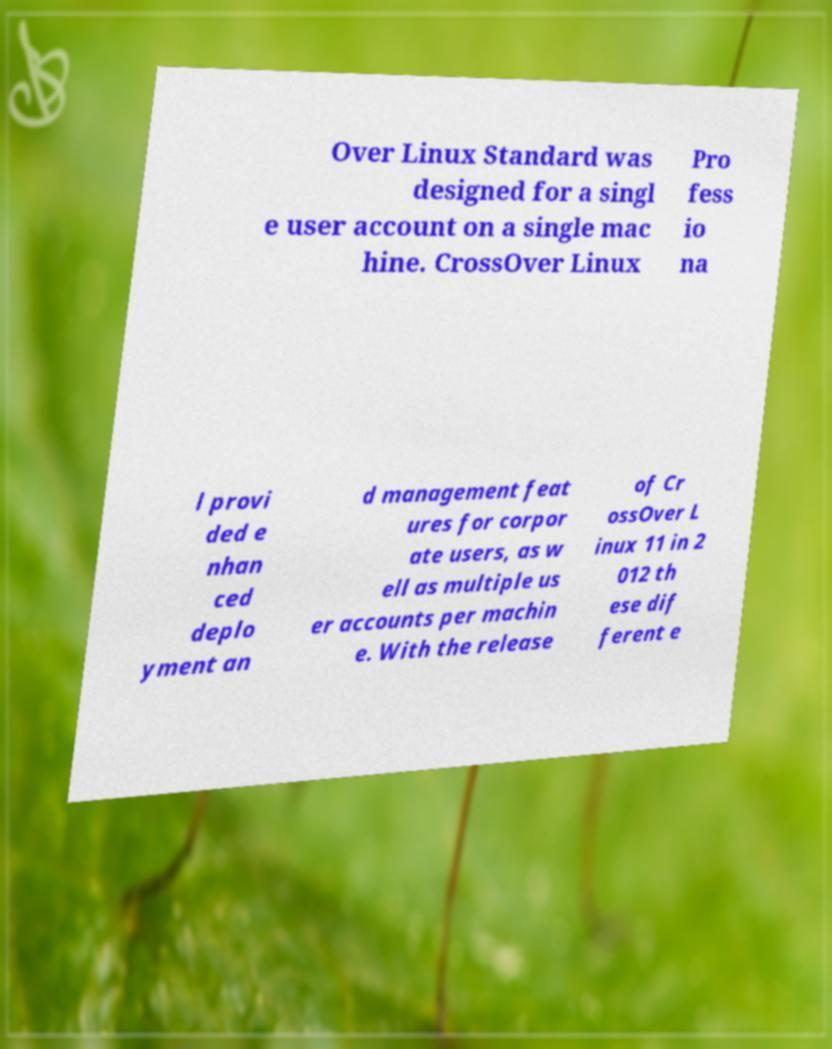Can you read and provide the text displayed in the image?This photo seems to have some interesting text. Can you extract and type it out for me? Over Linux Standard was designed for a singl e user account on a single mac hine. CrossOver Linux Pro fess io na l provi ded e nhan ced deplo yment an d management feat ures for corpor ate users, as w ell as multiple us er accounts per machin e. With the release of Cr ossOver L inux 11 in 2 012 th ese dif ferent e 